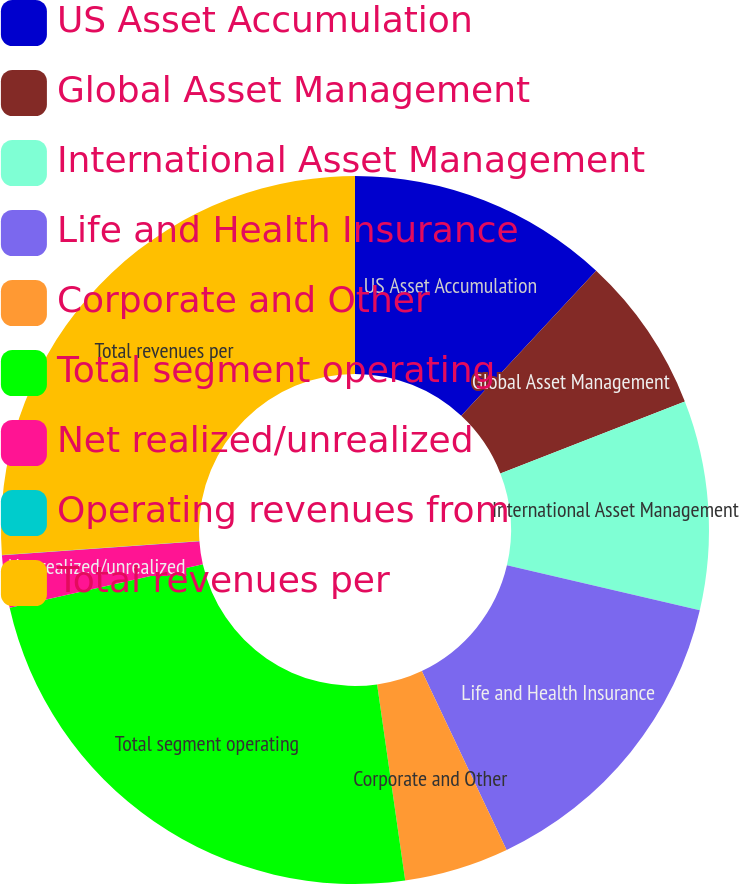<chart> <loc_0><loc_0><loc_500><loc_500><pie_chart><fcel>US Asset Accumulation<fcel>Global Asset Management<fcel>International Asset Management<fcel>Life and Health Insurance<fcel>Corporate and Other<fcel>Total segment operating<fcel>Net realized/unrealized<fcel>Operating revenues from<fcel>Total revenues per<nl><fcel>11.93%<fcel>7.16%<fcel>9.55%<fcel>14.32%<fcel>4.78%<fcel>23.74%<fcel>2.39%<fcel>0.01%<fcel>26.13%<nl></chart> 